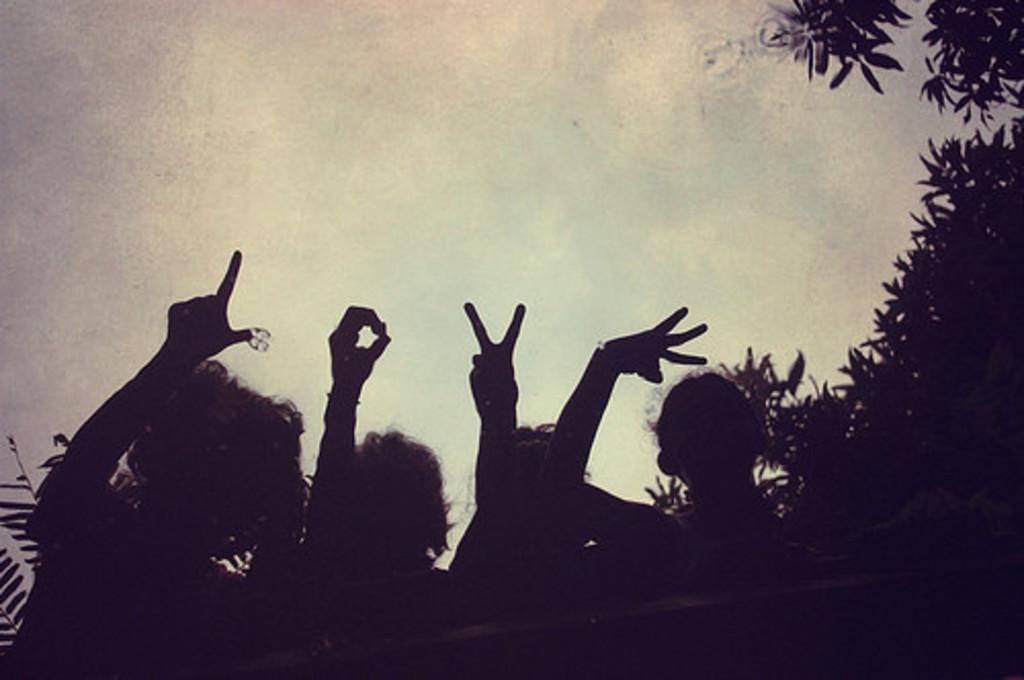Please provide a concise description of this image. At the bottom of the picture, we see four children are standing. They are posing for the photo. They are making alphabet with their fingers. On the right side, we see the trees. At the top, we see the sky. 